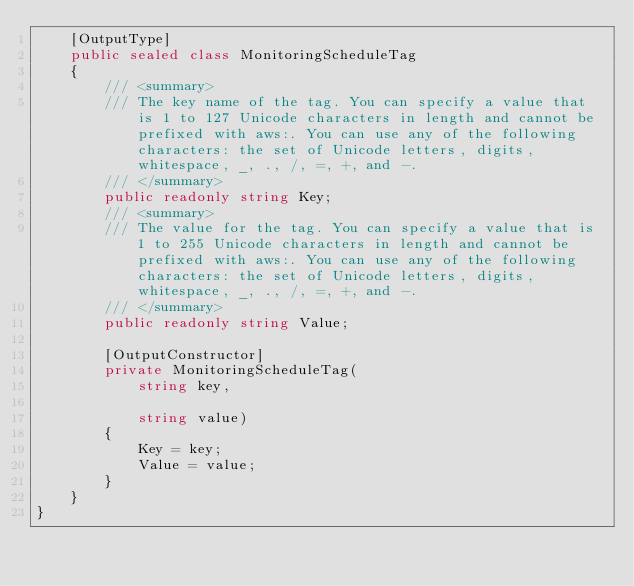Convert code to text. <code><loc_0><loc_0><loc_500><loc_500><_C#_>    [OutputType]
    public sealed class MonitoringScheduleTag
    {
        /// <summary>
        /// The key name of the tag. You can specify a value that is 1 to 127 Unicode characters in length and cannot be prefixed with aws:. You can use any of the following characters: the set of Unicode letters, digits, whitespace, _, ., /, =, +, and -. 
        /// </summary>
        public readonly string Key;
        /// <summary>
        /// The value for the tag. You can specify a value that is 1 to 255 Unicode characters in length and cannot be prefixed with aws:. You can use any of the following characters: the set of Unicode letters, digits, whitespace, _, ., /, =, +, and -. 
        /// </summary>
        public readonly string Value;

        [OutputConstructor]
        private MonitoringScheduleTag(
            string key,

            string value)
        {
            Key = key;
            Value = value;
        }
    }
}
</code> 